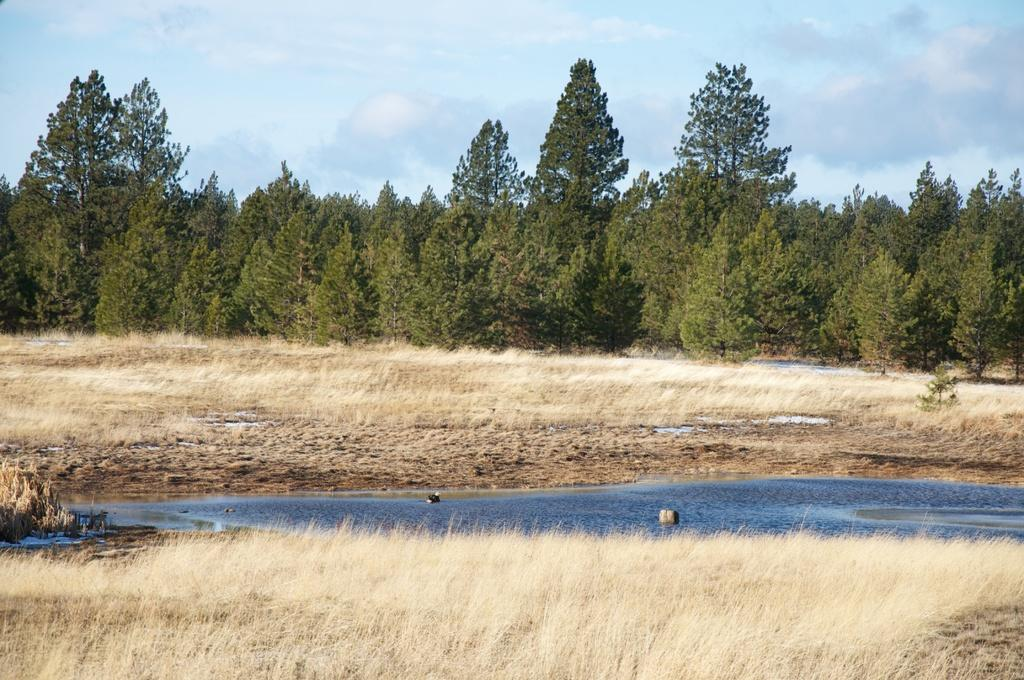What type of vegetation is present in the image? There are dried plants in the image. What natural feature can be seen in the image? There is a water body in the image. What else can be seen in the image besides the dried plants and water body? There is a group of trees in the image. How would you describe the sky in the image? The sky is visible in the image and appears cloudy. What type of flowers can be seen growing on the square canvas in the image? There is no square canvas or flowers present in the image. 